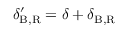Convert formula to latex. <formula><loc_0><loc_0><loc_500><loc_500>\delta _ { B , R } ^ { \prime } = \delta + \delta _ { B , R }</formula> 